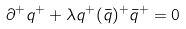<formula> <loc_0><loc_0><loc_500><loc_500>\partial ^ { + } q ^ { + } + \lambda { q ^ { + } ( \bar { q } ) ^ { + } } { \bar { q } } ^ { + } = 0</formula> 